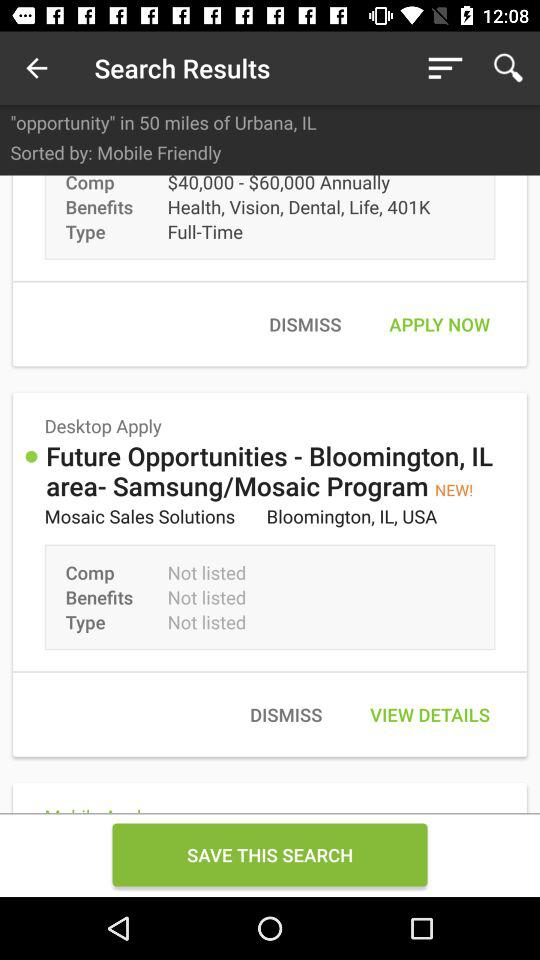What option is selected for "Sorted by"? The selected option for "Sorted by" is "Mobile Friendly". 